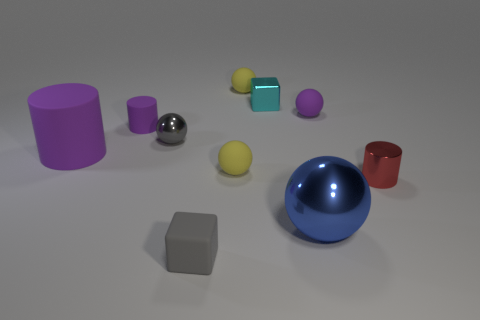What is the material of the purple cylinder that is the same size as the blue ball?
Ensure brevity in your answer.  Rubber. What number of objects are either blue spheres or purple objects that are left of the tiny gray metal thing?
Keep it short and to the point. 3. Does the gray sphere have the same size as the purple matte object that is in front of the gray metallic object?
Your response must be concise. No. How many cylinders are big purple metallic objects or tiny red objects?
Your answer should be very brief. 1. What number of purple matte things are both to the left of the gray shiny sphere and behind the big rubber cylinder?
Your answer should be very brief. 1. What number of other things are the same color as the large shiny ball?
Provide a succinct answer. 0. The gray thing that is in front of the small red metallic cylinder has what shape?
Keep it short and to the point. Cube. Does the large cylinder have the same material as the small red thing?
Your answer should be very brief. No. There is a blue thing; how many rubber cylinders are in front of it?
Your answer should be very brief. 0. There is a tiny yellow matte object behind the tiny cube behind the large matte cylinder; what is its shape?
Make the answer very short. Sphere. 